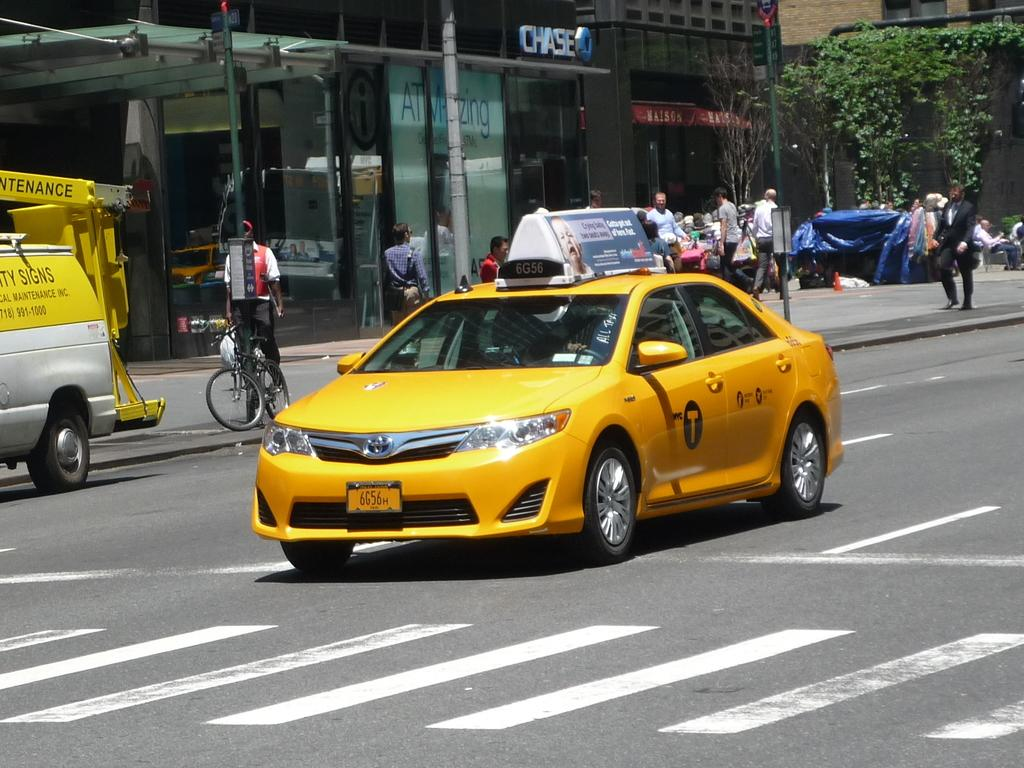<image>
Write a terse but informative summary of the picture. A taxi with the license plate 6G56H drives down a city street. 